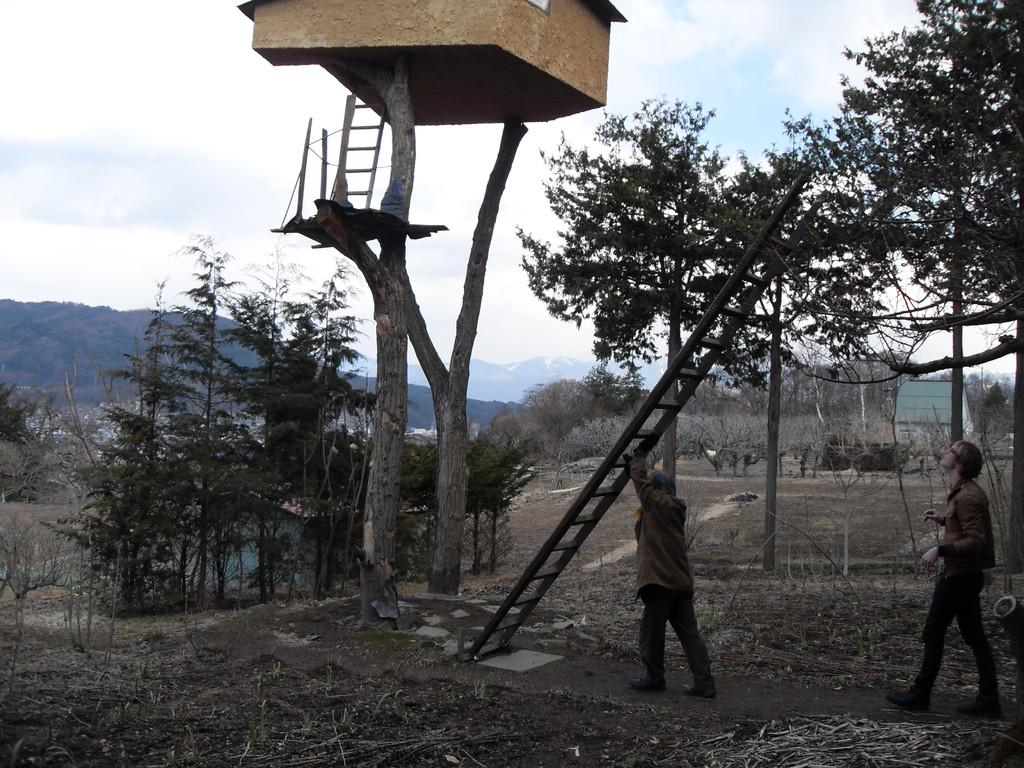What is the person in the image carrying? The person in the image is carrying a ladder. What is the person with the ladder doing? The person with the ladder is walking. Are there any other people in the image? Yes, there is another person walking in the image. What can be seen in the background of the image? There are trees and mountains in the background of the image. What advice does the person carrying the ladder give to the other person in the image? There is no indication in the image that the person carrying the ladder is giving advice to the other person. 